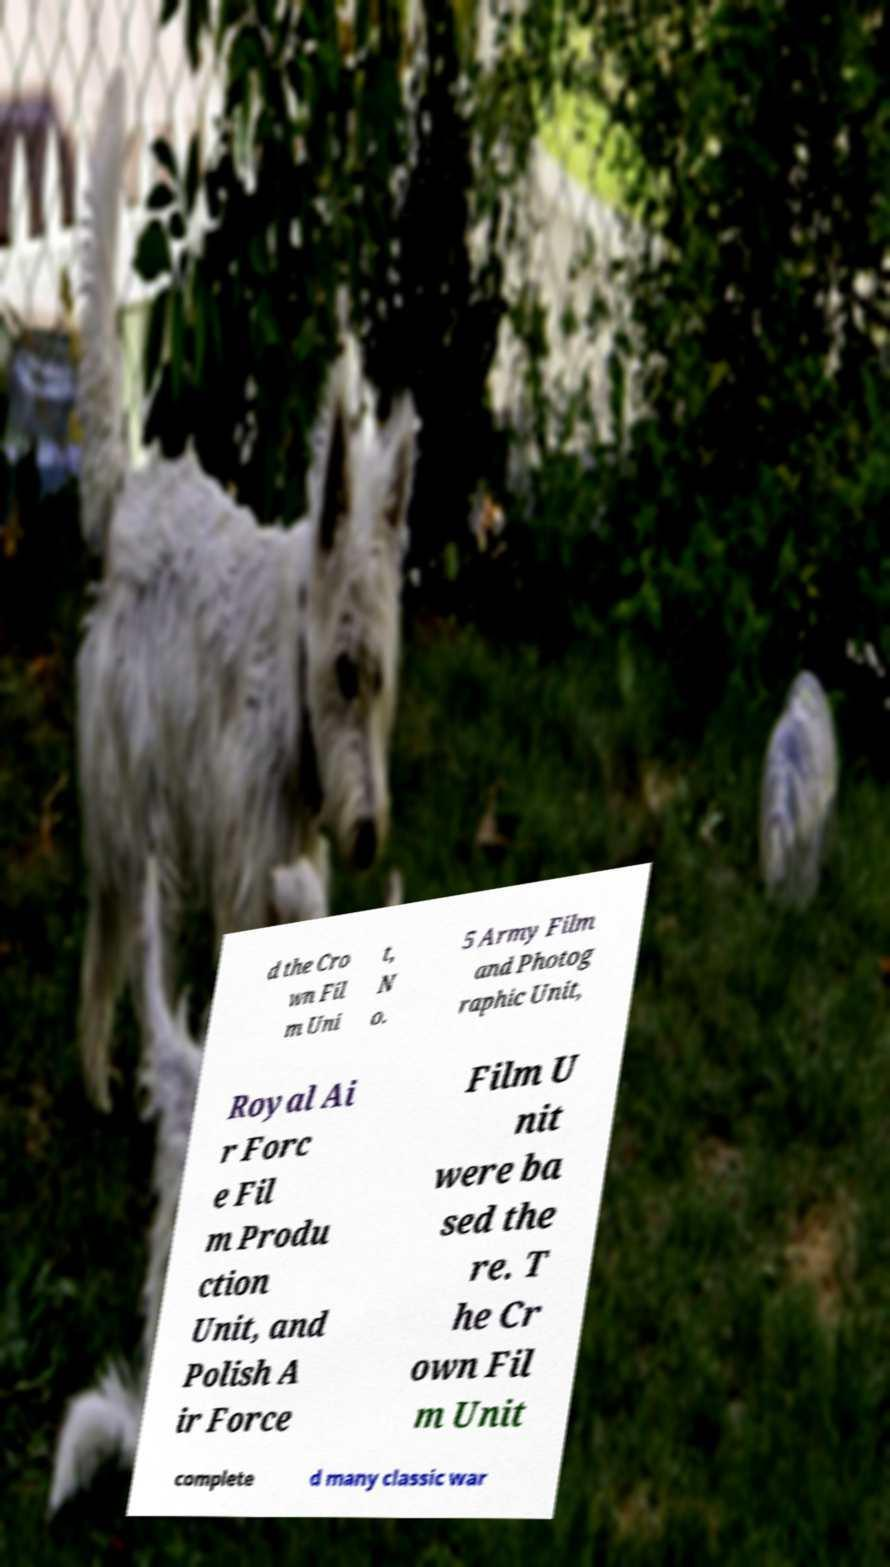Could you assist in decoding the text presented in this image and type it out clearly? d the Cro wn Fil m Uni t, N o. 5 Army Film and Photog raphic Unit, Royal Ai r Forc e Fil m Produ ction Unit, and Polish A ir Force Film U nit were ba sed the re. T he Cr own Fil m Unit complete d many classic war 